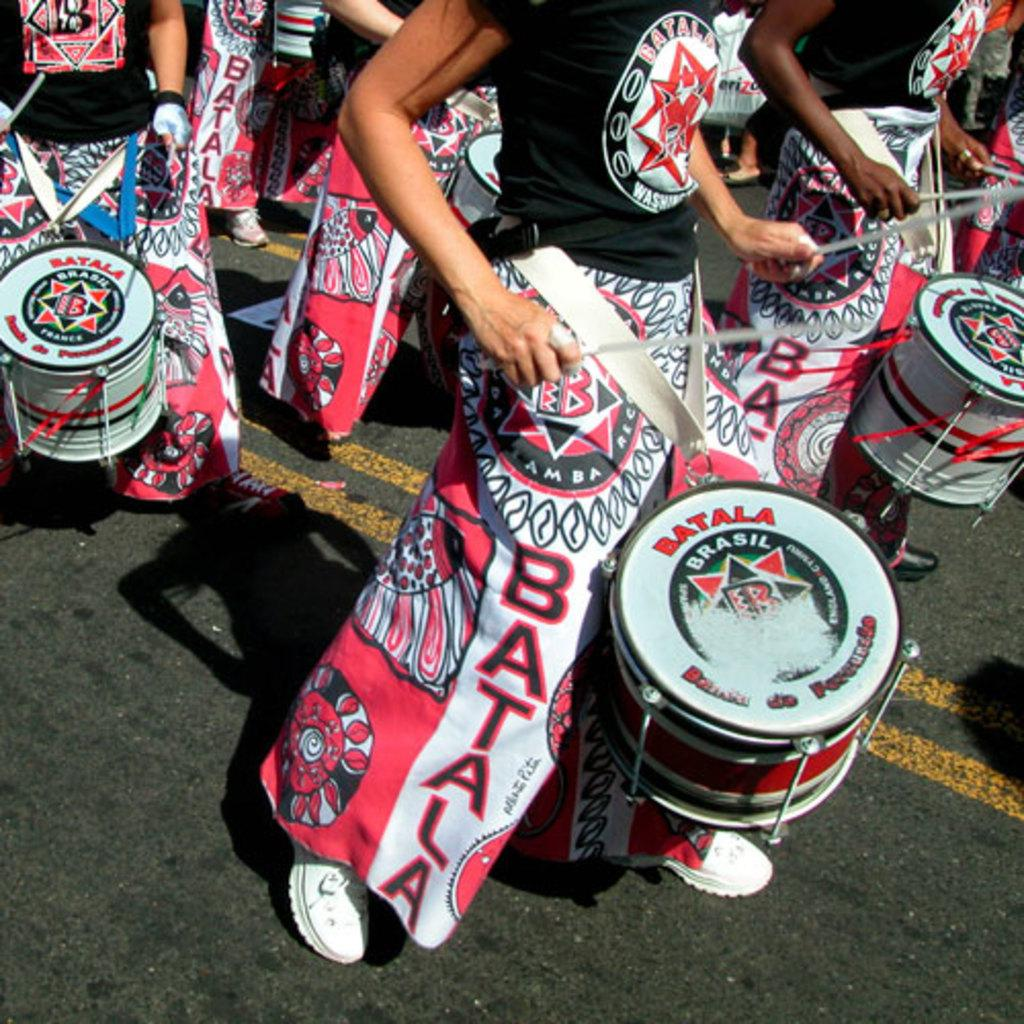<image>
Describe the image concisely. A group of people playing the snare drums wearing Batala pants and holding Batala drums. 